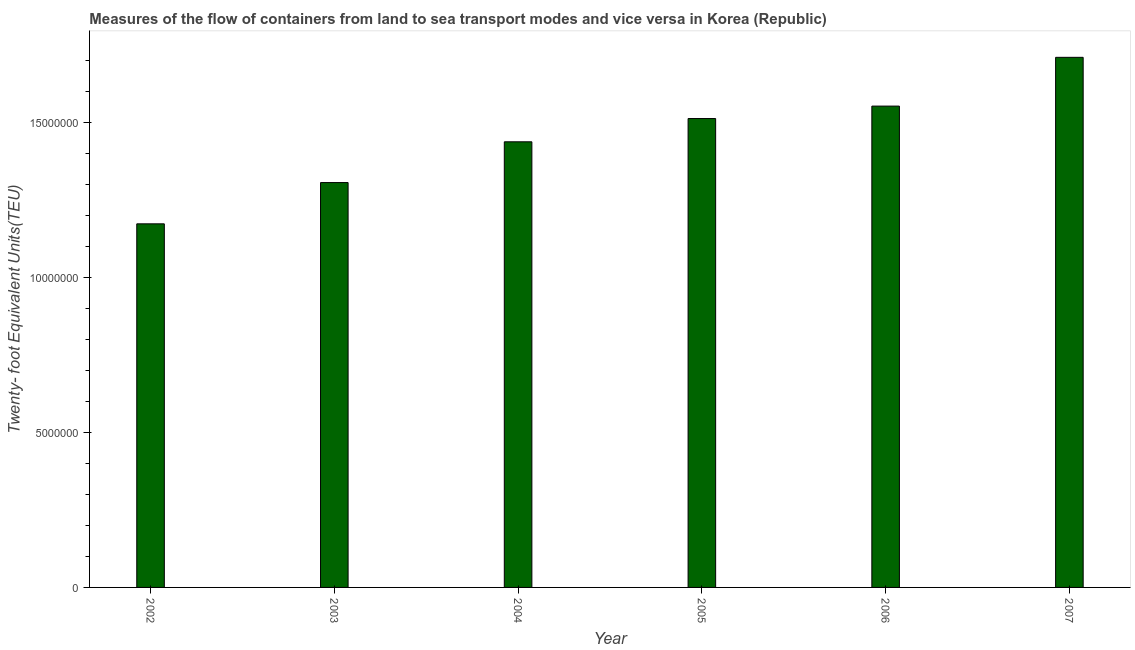Does the graph contain any zero values?
Your response must be concise. No. What is the title of the graph?
Provide a short and direct response. Measures of the flow of containers from land to sea transport modes and vice versa in Korea (Republic). What is the label or title of the X-axis?
Make the answer very short. Year. What is the label or title of the Y-axis?
Offer a very short reply. Twenty- foot Equivalent Units(TEU). What is the container port traffic in 2005?
Give a very brief answer. 1.51e+07. Across all years, what is the maximum container port traffic?
Provide a short and direct response. 1.71e+07. Across all years, what is the minimum container port traffic?
Make the answer very short. 1.17e+07. What is the sum of the container port traffic?
Offer a terse response. 8.68e+07. What is the difference between the container port traffic in 2002 and 2003?
Provide a succinct answer. -1.33e+06. What is the average container port traffic per year?
Provide a succinct answer. 1.45e+07. What is the median container port traffic?
Provide a short and direct response. 1.47e+07. In how many years, is the container port traffic greater than 5000000 TEU?
Your response must be concise. 6. What is the ratio of the container port traffic in 2002 to that in 2005?
Your answer should be very brief. 0.78. Is the container port traffic in 2004 less than that in 2007?
Make the answer very short. Yes. What is the difference between the highest and the second highest container port traffic?
Provide a succinct answer. 1.57e+06. What is the difference between the highest and the lowest container port traffic?
Your answer should be compact. 5.37e+06. In how many years, is the container port traffic greater than the average container port traffic taken over all years?
Keep it short and to the point. 3. What is the difference between two consecutive major ticks on the Y-axis?
Offer a very short reply. 5.00e+06. What is the Twenty- foot Equivalent Units(TEU) of 2002?
Offer a very short reply. 1.17e+07. What is the Twenty- foot Equivalent Units(TEU) of 2003?
Offer a terse response. 1.30e+07. What is the Twenty- foot Equivalent Units(TEU) of 2004?
Give a very brief answer. 1.44e+07. What is the Twenty- foot Equivalent Units(TEU) of 2005?
Offer a terse response. 1.51e+07. What is the Twenty- foot Equivalent Units(TEU) in 2006?
Give a very brief answer. 1.55e+07. What is the Twenty- foot Equivalent Units(TEU) of 2007?
Make the answer very short. 1.71e+07. What is the difference between the Twenty- foot Equivalent Units(TEU) in 2002 and 2003?
Your answer should be very brief. -1.33e+06. What is the difference between the Twenty- foot Equivalent Units(TEU) in 2002 and 2004?
Offer a very short reply. -2.64e+06. What is the difference between the Twenty- foot Equivalent Units(TEU) in 2002 and 2005?
Offer a very short reply. -3.39e+06. What is the difference between the Twenty- foot Equivalent Units(TEU) in 2002 and 2006?
Provide a succinct answer. -3.79e+06. What is the difference between the Twenty- foot Equivalent Units(TEU) in 2002 and 2007?
Your answer should be compact. -5.37e+06. What is the difference between the Twenty- foot Equivalent Units(TEU) in 2003 and 2004?
Offer a terse response. -1.31e+06. What is the difference between the Twenty- foot Equivalent Units(TEU) in 2003 and 2005?
Your answer should be very brief. -2.06e+06. What is the difference between the Twenty- foot Equivalent Units(TEU) in 2003 and 2006?
Your answer should be very brief. -2.46e+06. What is the difference between the Twenty- foot Equivalent Units(TEU) in 2003 and 2007?
Keep it short and to the point. -4.04e+06. What is the difference between the Twenty- foot Equivalent Units(TEU) in 2004 and 2005?
Your answer should be very brief. -7.50e+05. What is the difference between the Twenty- foot Equivalent Units(TEU) in 2004 and 2006?
Provide a short and direct response. -1.15e+06. What is the difference between the Twenty- foot Equivalent Units(TEU) in 2004 and 2007?
Provide a short and direct response. -2.72e+06. What is the difference between the Twenty- foot Equivalent Units(TEU) in 2005 and 2006?
Provide a short and direct response. -4.01e+05. What is the difference between the Twenty- foot Equivalent Units(TEU) in 2005 and 2007?
Provide a short and direct response. -1.97e+06. What is the difference between the Twenty- foot Equivalent Units(TEU) in 2006 and 2007?
Provide a short and direct response. -1.57e+06. What is the ratio of the Twenty- foot Equivalent Units(TEU) in 2002 to that in 2003?
Offer a terse response. 0.9. What is the ratio of the Twenty- foot Equivalent Units(TEU) in 2002 to that in 2004?
Keep it short and to the point. 0.82. What is the ratio of the Twenty- foot Equivalent Units(TEU) in 2002 to that in 2005?
Your answer should be compact. 0.78. What is the ratio of the Twenty- foot Equivalent Units(TEU) in 2002 to that in 2006?
Give a very brief answer. 0.76. What is the ratio of the Twenty- foot Equivalent Units(TEU) in 2002 to that in 2007?
Provide a succinct answer. 0.69. What is the ratio of the Twenty- foot Equivalent Units(TEU) in 2003 to that in 2004?
Provide a short and direct response. 0.91. What is the ratio of the Twenty- foot Equivalent Units(TEU) in 2003 to that in 2005?
Make the answer very short. 0.86. What is the ratio of the Twenty- foot Equivalent Units(TEU) in 2003 to that in 2006?
Keep it short and to the point. 0.84. What is the ratio of the Twenty- foot Equivalent Units(TEU) in 2003 to that in 2007?
Keep it short and to the point. 0.76. What is the ratio of the Twenty- foot Equivalent Units(TEU) in 2004 to that in 2005?
Your answer should be very brief. 0.95. What is the ratio of the Twenty- foot Equivalent Units(TEU) in 2004 to that in 2006?
Your answer should be very brief. 0.93. What is the ratio of the Twenty- foot Equivalent Units(TEU) in 2004 to that in 2007?
Offer a very short reply. 0.84. What is the ratio of the Twenty- foot Equivalent Units(TEU) in 2005 to that in 2007?
Your answer should be very brief. 0.89. What is the ratio of the Twenty- foot Equivalent Units(TEU) in 2006 to that in 2007?
Offer a terse response. 0.91. 